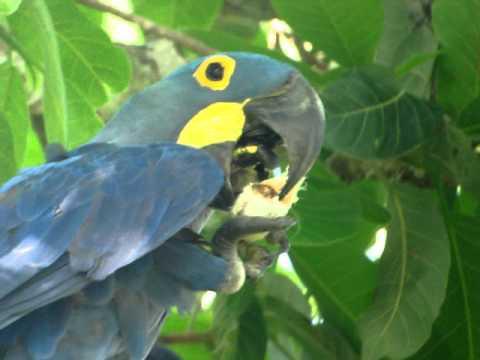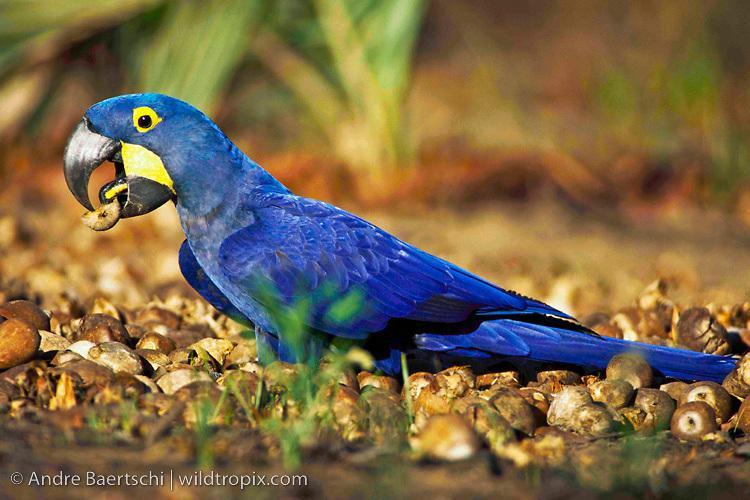The first image is the image on the left, the second image is the image on the right. Evaluate the accuracy of this statement regarding the images: "An image shows one blue parrot perched on a stub-ended leafless branch.". Is it true? Answer yes or no. No. The first image is the image on the left, the second image is the image on the right. For the images shown, is this caption "The right image contains no more than one blue parrot that is facing towards the left." true? Answer yes or no. Yes. 